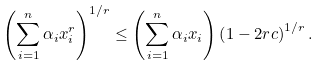<formula> <loc_0><loc_0><loc_500><loc_500>\left ( \sum _ { i = 1 } ^ { n } \alpha _ { i } x _ { i } ^ { r } \right ) ^ { 1 / r } \leq \left ( \sum _ { i = 1 } ^ { n } \alpha _ { i } x _ { i } \right ) \left ( 1 - 2 r c \right ) ^ { 1 / r } .</formula> 